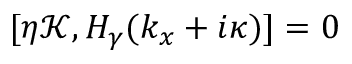<formula> <loc_0><loc_0><loc_500><loc_500>\begin{array} { r } { [ \eta \mathcal { K } , H _ { \gamma } ( k _ { x } + i \kappa ) ] = 0 } \end{array}</formula> 